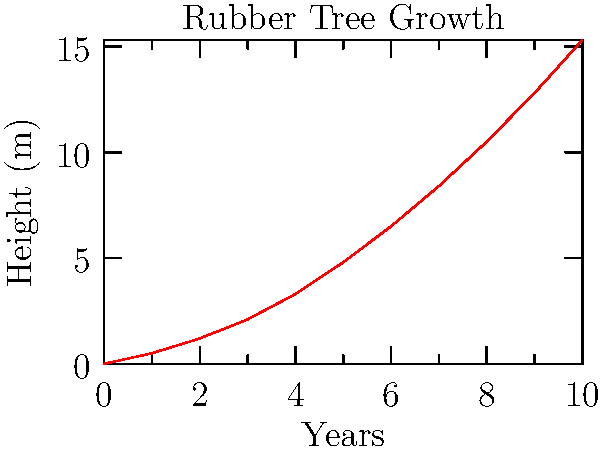The graph shows the growth pattern of a rubber tree over a 10-year period. If this trend continues, what would be the approximate height of the tree at the 15-year mark? How does this growth pattern inform your sustainable plantation management practices? To answer this question, we need to analyze the growth pattern and extrapolate it to the 15-year mark. Let's break it down step-by-step:

1. Observe the growth pattern:
   The graph shows a non-linear growth pattern, indicating that the tree grows faster as it gets older.

2. Calculate the growth rate:
   - At year 5: 4.8 m
   - At year 10: 15.3 m
   - Growth in the second 5-year period: 15.3 m - 4.8 m = 10.5 m

3. Estimate the growth for the next 5-year period:
   Assuming the acceleration in growth continues, we can expect the growth in the third 5-year period to be greater than 10.5 m.

4. Extrapolate to year 15:
   A conservative estimate would be to add at least 10.5 m to the height at year 10.
   15.3 m + 10.5 m = 25.8 m

5. Consider sustainable plantation management:
   - This rapid growth pattern suggests that rubber trees reach a harvestable size relatively quickly.
   - It informs decisions on planting cycles, allowing for efficient use of land and resources.
   - The non-linear growth indicates that trees become more productive as they age, which might influence decisions on when to harvest or replant.
   - Understanding this growth pattern helps in planning long-term sustainability and maintaining a consistent supply of ethically sourced wood.
Answer: Approximately 25.8 m at 15 years; informs efficient planting cycles and harvest timing for sustainable management. 